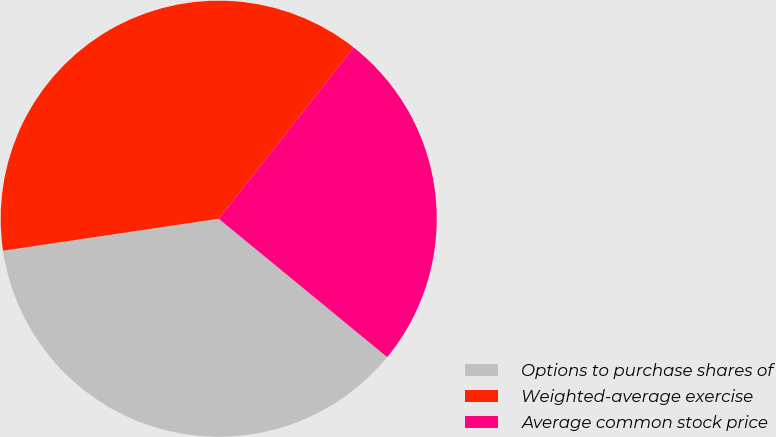<chart> <loc_0><loc_0><loc_500><loc_500><pie_chart><fcel>Options to purchase shares of<fcel>Weighted-average exercise<fcel>Average common stock price<nl><fcel>36.71%<fcel>37.97%<fcel>25.32%<nl></chart> 